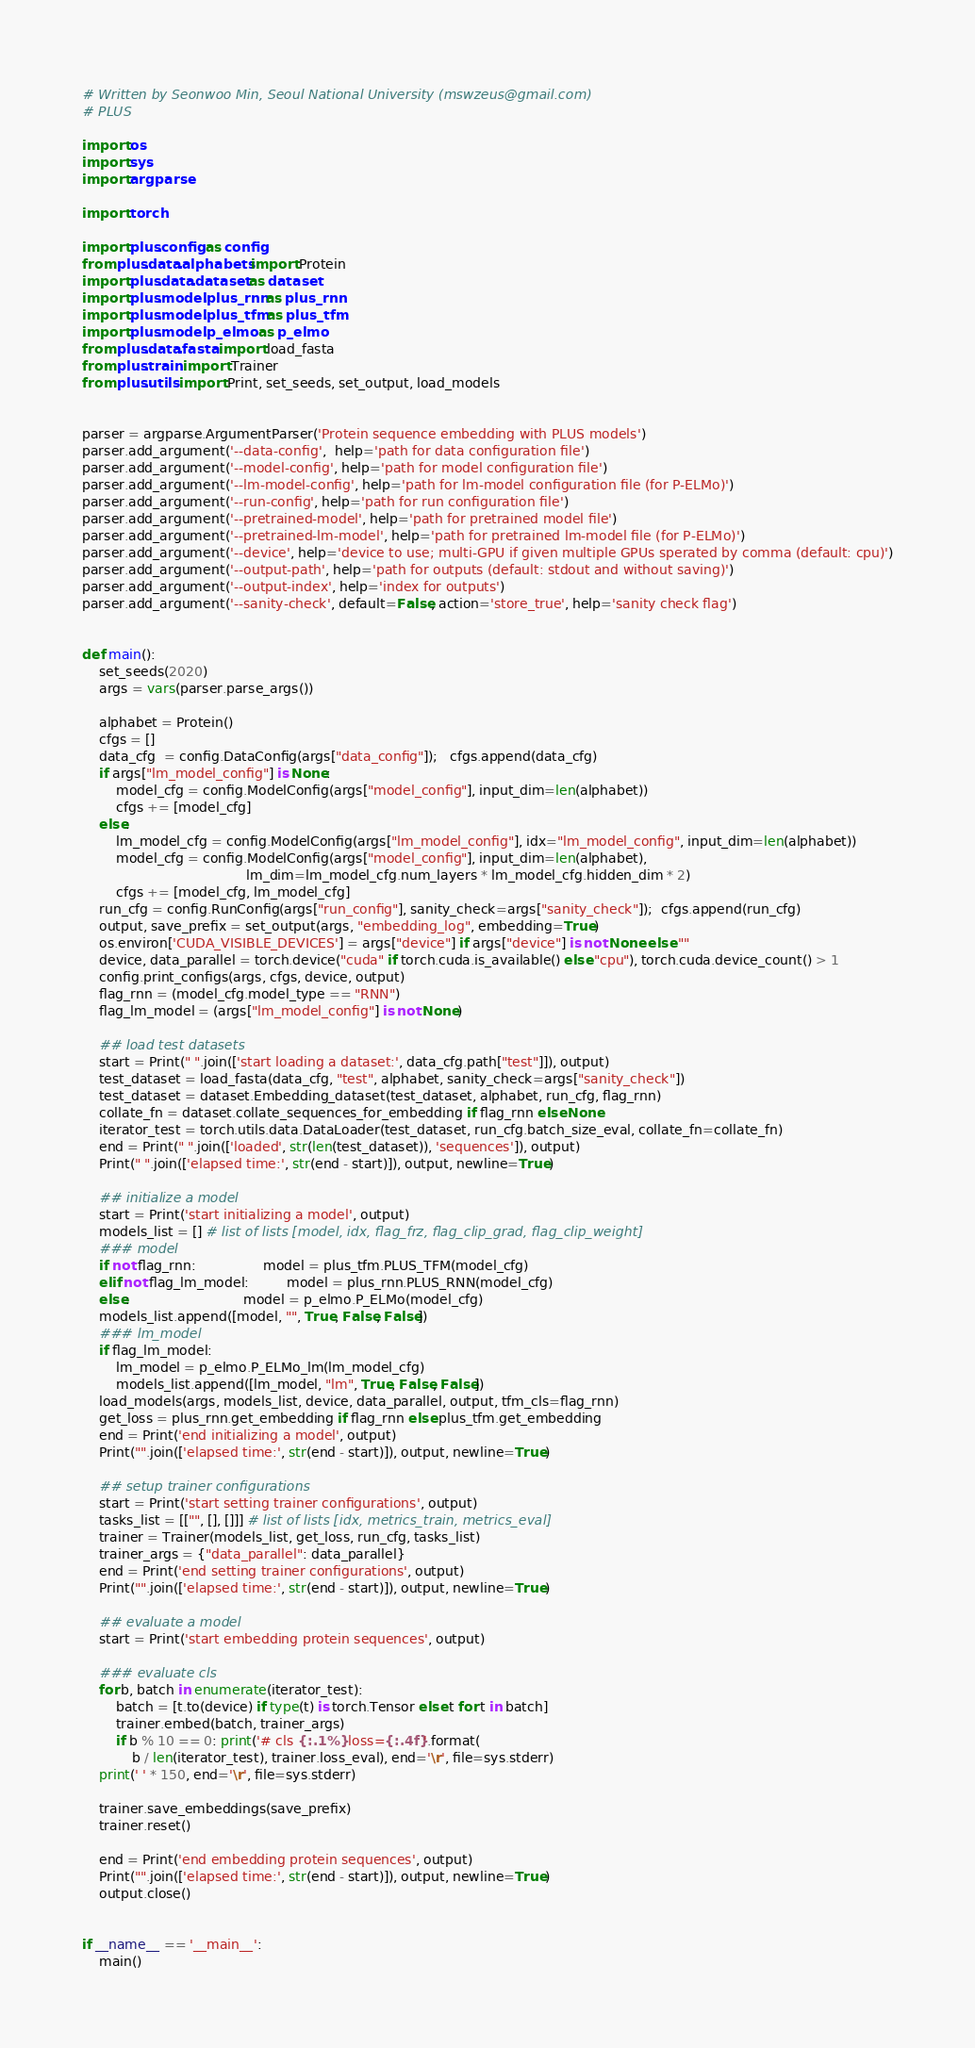<code> <loc_0><loc_0><loc_500><loc_500><_Python_># Written by Seonwoo Min, Seoul National University (mswzeus@gmail.com)
# PLUS

import os
import sys
import argparse

import torch

import plus.config as config
from plus.data.alphabets import Protein
import plus.data.dataset as dataset
import plus.model.plus_rnn as plus_rnn
import plus.model.plus_tfm as plus_tfm
import plus.model.p_elmo as p_elmo
from plus.data.fasta import load_fasta
from plus.train import Trainer
from plus.utils import Print, set_seeds, set_output, load_models


parser = argparse.ArgumentParser('Protein sequence embedding with PLUS models')
parser.add_argument('--data-config',  help='path for data configuration file')
parser.add_argument('--model-config', help='path for model configuration file')
parser.add_argument('--lm-model-config', help='path for lm-model configuration file (for P-ELMo)')
parser.add_argument('--run-config', help='path for run configuration file')
parser.add_argument('--pretrained-model', help='path for pretrained model file')
parser.add_argument('--pretrained-lm-model', help='path for pretrained lm-model file (for P-ELMo)')
parser.add_argument('--device', help='device to use; multi-GPU if given multiple GPUs sperated by comma (default: cpu)')
parser.add_argument('--output-path', help='path for outputs (default: stdout and without saving)')
parser.add_argument('--output-index', help='index for outputs')
parser.add_argument('--sanity-check', default=False, action='store_true', help='sanity check flag')


def main():
    set_seeds(2020)
    args = vars(parser.parse_args())

    alphabet = Protein()
    cfgs = []
    data_cfg  = config.DataConfig(args["data_config"]);   cfgs.append(data_cfg)
    if args["lm_model_config"] is None:
        model_cfg = config.ModelConfig(args["model_config"], input_dim=len(alphabet))
        cfgs += [model_cfg]
    else:
        lm_model_cfg = config.ModelConfig(args["lm_model_config"], idx="lm_model_config", input_dim=len(alphabet))
        model_cfg = config.ModelConfig(args["model_config"], input_dim=len(alphabet),
                                       lm_dim=lm_model_cfg.num_layers * lm_model_cfg.hidden_dim * 2)
        cfgs += [model_cfg, lm_model_cfg]
    run_cfg = config.RunConfig(args["run_config"], sanity_check=args["sanity_check"]);  cfgs.append(run_cfg)
    output, save_prefix = set_output(args, "embedding_log", embedding=True)
    os.environ['CUDA_VISIBLE_DEVICES'] = args["device"] if args["device"] is not None else ""
    device, data_parallel = torch.device("cuda" if torch.cuda.is_available() else "cpu"), torch.cuda.device_count() > 1
    config.print_configs(args, cfgs, device, output)
    flag_rnn = (model_cfg.model_type == "RNN")
    flag_lm_model = (args["lm_model_config"] is not None)

    ## load test datasets
    start = Print(" ".join(['start loading a dataset:', data_cfg.path["test"]]), output)
    test_dataset = load_fasta(data_cfg, "test", alphabet, sanity_check=args["sanity_check"])
    test_dataset = dataset.Embedding_dataset(test_dataset, alphabet, run_cfg, flag_rnn)
    collate_fn = dataset.collate_sequences_for_embedding if flag_rnn else None
    iterator_test = torch.utils.data.DataLoader(test_dataset, run_cfg.batch_size_eval, collate_fn=collate_fn)
    end = Print(" ".join(['loaded', str(len(test_dataset)), 'sequences']), output)
    Print(" ".join(['elapsed time:', str(end - start)]), output, newline=True)

    ## initialize a model
    start = Print('start initializing a model', output)
    models_list = [] # list of lists [model, idx, flag_frz, flag_clip_grad, flag_clip_weight]
    ### model
    if not flag_rnn:                model = plus_tfm.PLUS_TFM(model_cfg)
    elif not flag_lm_model:         model = plus_rnn.PLUS_RNN(model_cfg)
    else:                           model = p_elmo.P_ELMo(model_cfg)
    models_list.append([model, "", True, False, False])
    ### lm_model
    if flag_lm_model:
        lm_model = p_elmo.P_ELMo_lm(lm_model_cfg)
        models_list.append([lm_model, "lm", True, False, False])
    load_models(args, models_list, device, data_parallel, output, tfm_cls=flag_rnn)
    get_loss = plus_rnn.get_embedding if flag_rnn else plus_tfm.get_embedding
    end = Print('end initializing a model', output)
    Print("".join(['elapsed time:', str(end - start)]), output, newline=True)

    ## setup trainer configurations
    start = Print('start setting trainer configurations', output)
    tasks_list = [["", [], []]] # list of lists [idx, metrics_train, metrics_eval]
    trainer = Trainer(models_list, get_loss, run_cfg, tasks_list)
    trainer_args = {"data_parallel": data_parallel}
    end = Print('end setting trainer configurations', output)
    Print("".join(['elapsed time:', str(end - start)]), output, newline=True)

    ## evaluate a model
    start = Print('start embedding protein sequences', output)

    ### evaluate cls
    for b, batch in enumerate(iterator_test):
        batch = [t.to(device) if type(t) is torch.Tensor else t for t in batch]
        trainer.embed(batch, trainer_args)
        if b % 10 == 0: print('# cls {:.1%} loss={:.4f}'.format(
            b / len(iterator_test), trainer.loss_eval), end='\r', file=sys.stderr)
    print(' ' * 150, end='\r', file=sys.stderr)

    trainer.save_embeddings(save_prefix)
    trainer.reset()

    end = Print('end embedding protein sequences', output)
    Print("".join(['elapsed time:', str(end - start)]), output, newline=True)
    output.close()


if __name__ == '__main__':
    main()</code> 